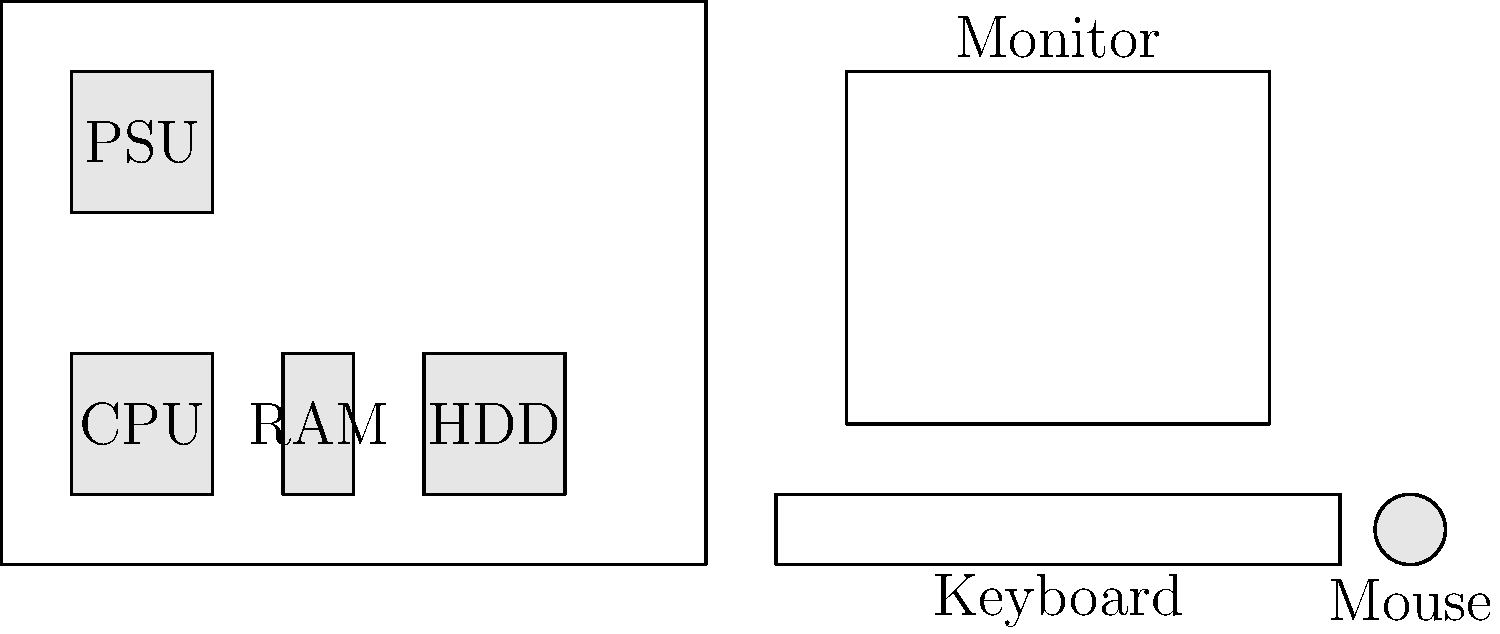As a tech-savvy mom creating educational content for your children, you want to teach them about computer parts. Using the labeled diagram, which component is responsible for storing data and programs when the computer is turned off? Let's break down the main components of a computer and their functions:

1. CPU (Central Processing Unit): This is the "brain" of the computer, responsible for executing instructions and performing calculations.

2. RAM (Random Access Memory): This is temporary memory that stores data and programs currently in use. It's fast but volatile, meaning its contents are lost when the computer is turned off.

3. HDD (Hard Disk Drive): This is the component responsible for long-term storage of data and programs. It retains information even when the computer is turned off.

4. PSU (Power Supply Unit): This component provides power to all other parts of the computer.

5. Monitor: This is the display device that shows visual output from the computer.

6. Keyboard: This is an input device used to type information into the computer.

7. Mouse: This is another input device used for pointing and selecting objects on the screen.

Among these components, only the HDD (Hard Disk Drive) is designed to store data and programs permanently, even when the computer is turned off. The RAM, while also used for storage, is volatile and loses its contents when power is removed.
Answer: HDD (Hard Disk Drive) 